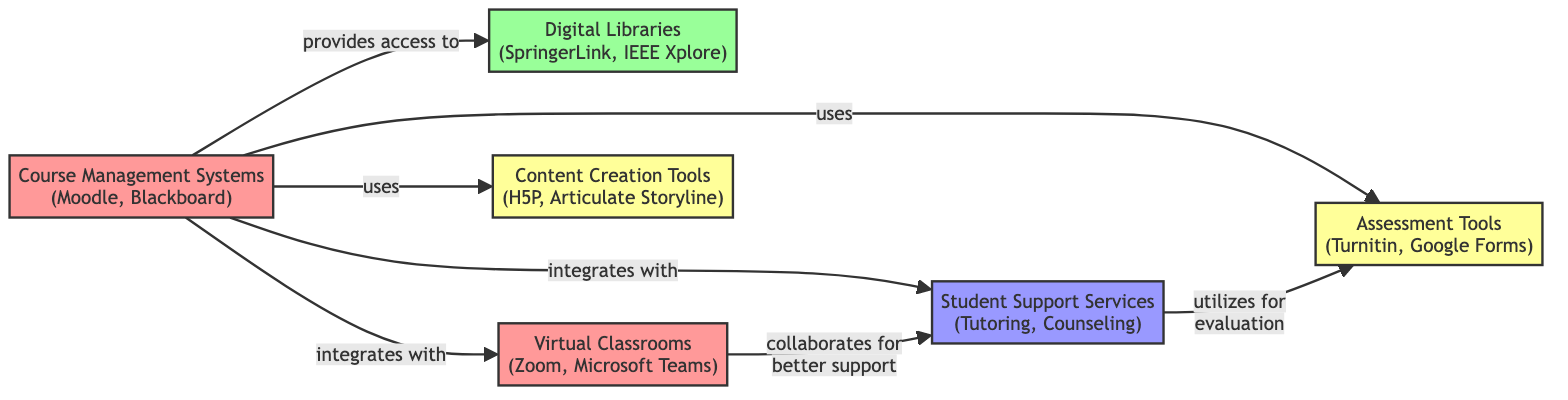What are the two entities in the Course Management Systems node? The Course Management Systems node lists two entities: Moodle and Blackboard. These names are provided directly in the node label.
Answer: Moodle, Blackboard How many nodes are present in the diagram? The diagram lists a total of six distinct nodes related to the digital learning ecosystem, which are visible through the labeled connections.
Answer: 6 Which system integrates with the Digital Libraries? According to the links in the diagram, the Course Management Systems node has a direct link that states it "provides access to" the Digital Libraries node, indicating an integration.
Answer: Course Management Systems What is the relationship between Virtual Classrooms and Student Support Services? The diagram indicates that the Virtual Classrooms node collaborates with the Student Support Services node to provide better support for students, establishing a direct relationship.
Answer: collaboration for better support Which tool is linked to the Course Management Systems for assessments? The diagram shows that Assessment Tools are used by the Course Management Systems as indicated by the connection labeled "uses assessment tools."
Answer: Assessment Tools What type of resource is represented by the Digital Libraries node? The Digital Libraries node is categorized as a resource according to the type definition in the diagram that assigns categories to each node.
Answer: resource How many types of entities are present in the diagram? By examining the various nodes and their classifications, we can see there are four distinct types: system, resource, service, and tool. This total represents the categories used to classify the nodes.
Answer: 4 Which entities belong to Content Creation Tools? The Content Creation Tools node specifies two entities, which are H5P and Articulate Storyline, as indicated in the node's label.
Answer: H5P, Articulate Storyline Which node utilizes assessment tools for student evaluation? The diagram reflects that the Student Support Services node has a link indicating it "utilizes assessment for student evaluation," clearly showing its role.
Answer: Student Support Services 